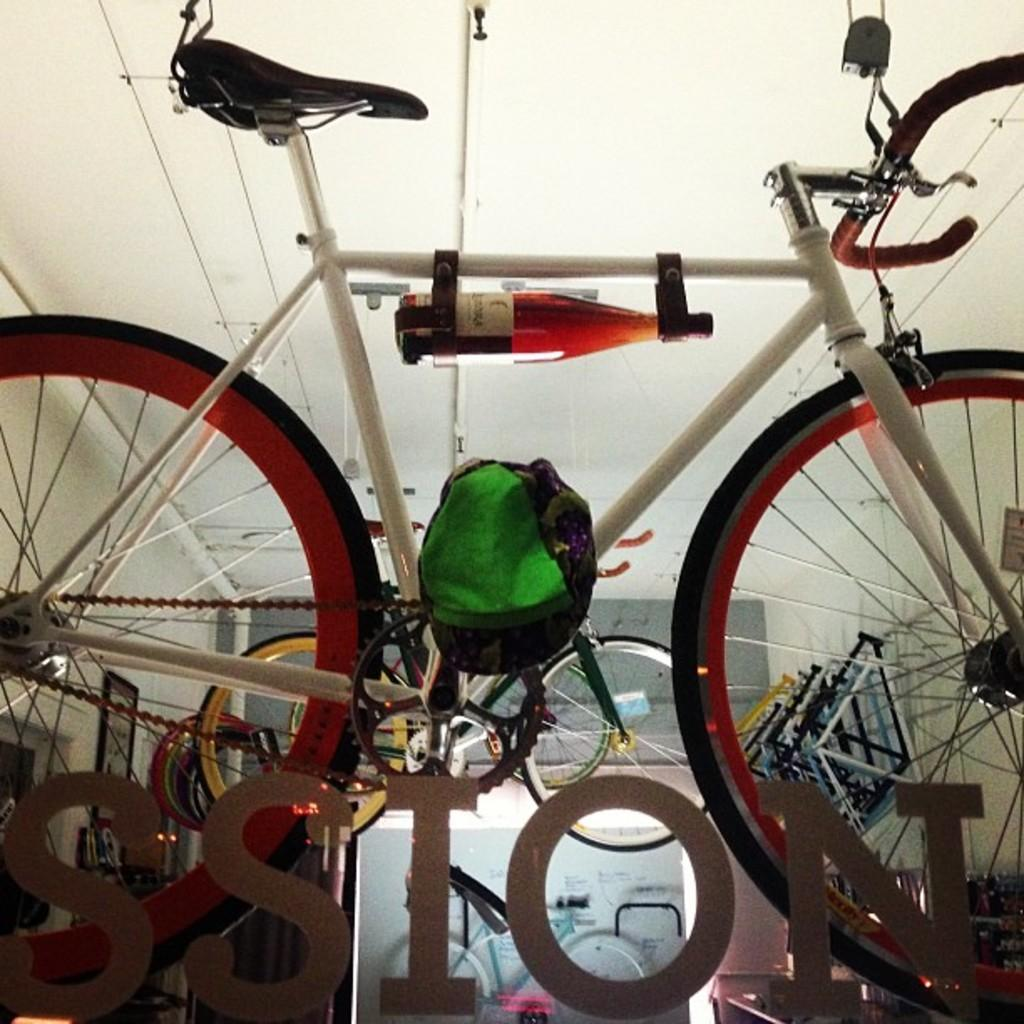What is the main subject in the foreground of the image? There is a bicycle in the foreground of the image. What can be found at the bottom side of the image? There is text at the bottom side of the image. Can you identify any other bicycles in the image? It appears that there is another bicycle in the image. What type of objects are present in the image that hold or support something? Metal holders are present in the image. What type of structures are visible in the image? Frames are visible in the image. What else can be seen in the background of the image? Other items are present in the background of the image. Can you see any goldfish swimming in the image? There are no goldfish present in the image. What type of emotion is the bicycle feeling in the image? Bicycles do not have emotions, so it is not possible to determine the emotion they might be feeling. 